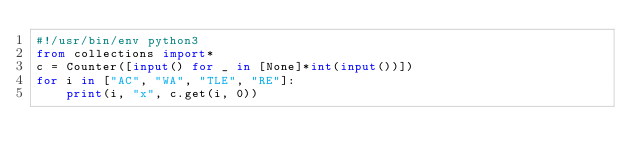<code> <loc_0><loc_0><loc_500><loc_500><_Python_>#!/usr/bin/env python3
from collections import*
c = Counter([input() for _ in [None]*int(input())])
for i in ["AC", "WA", "TLE", "RE"]:
    print(i, "x", c.get(i, 0))</code> 